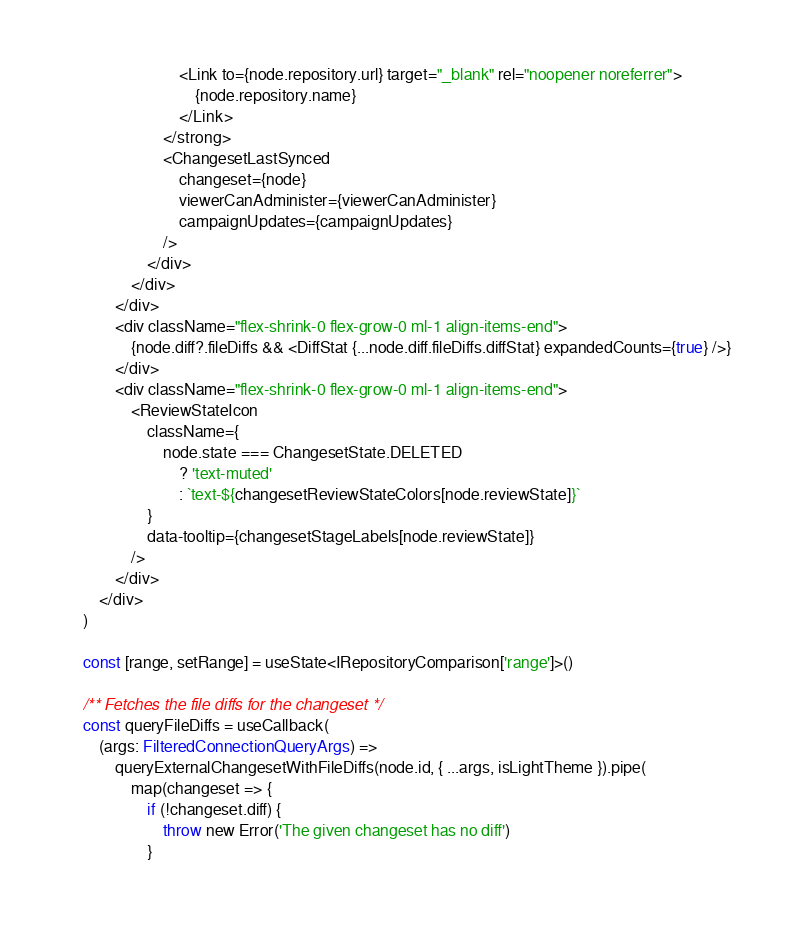Convert code to text. <code><loc_0><loc_0><loc_500><loc_500><_TypeScript_>                            <Link to={node.repository.url} target="_blank" rel="noopener noreferrer">
                                {node.repository.name}
                            </Link>
                        </strong>
                        <ChangesetLastSynced
                            changeset={node}
                            viewerCanAdminister={viewerCanAdminister}
                            campaignUpdates={campaignUpdates}
                        />
                    </div>
                </div>
            </div>
            <div className="flex-shrink-0 flex-grow-0 ml-1 align-items-end">
                {node.diff?.fileDiffs && <DiffStat {...node.diff.fileDiffs.diffStat} expandedCounts={true} />}
            </div>
            <div className="flex-shrink-0 flex-grow-0 ml-1 align-items-end">
                <ReviewStateIcon
                    className={
                        node.state === ChangesetState.DELETED
                            ? 'text-muted'
                            : `text-${changesetReviewStateColors[node.reviewState]}`
                    }
                    data-tooltip={changesetStageLabels[node.reviewState]}
                />
            </div>
        </div>
    )

    const [range, setRange] = useState<IRepositoryComparison['range']>()

    /** Fetches the file diffs for the changeset */
    const queryFileDiffs = useCallback(
        (args: FilteredConnectionQueryArgs) =>
            queryExternalChangesetWithFileDiffs(node.id, { ...args, isLightTheme }).pipe(
                map(changeset => {
                    if (!changeset.diff) {
                        throw new Error('The given changeset has no diff')
                    }</code> 